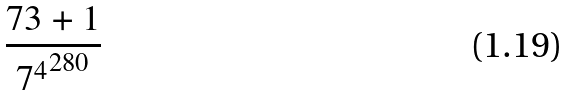<formula> <loc_0><loc_0><loc_500><loc_500>\frac { 7 3 + 1 } { { 7 ^ { 4 } } ^ { 2 8 0 } }</formula> 